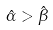<formula> <loc_0><loc_0><loc_500><loc_500>\hat { \alpha } > \hat { \beta }</formula> 